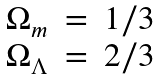<formula> <loc_0><loc_0><loc_500><loc_500>\begin{array} { l c l } \Omega _ { m } & = & 1 / 3 \\ \Omega _ { \Lambda } & = & 2 / 3 \end{array}</formula> 